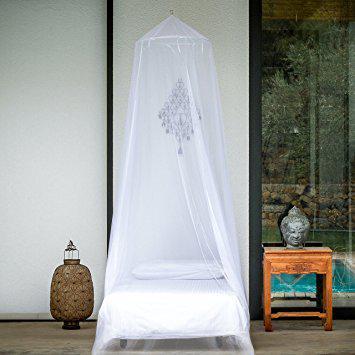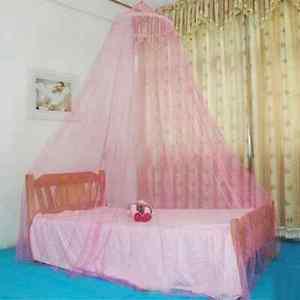The first image is the image on the left, the second image is the image on the right. Analyze the images presented: Is the assertion "There are two circle canopies." valid? Answer yes or no. Yes. The first image is the image on the left, the second image is the image on the right. Examine the images to the left and right. Is the description "There are two white round canopies." accurate? Answer yes or no. No. 